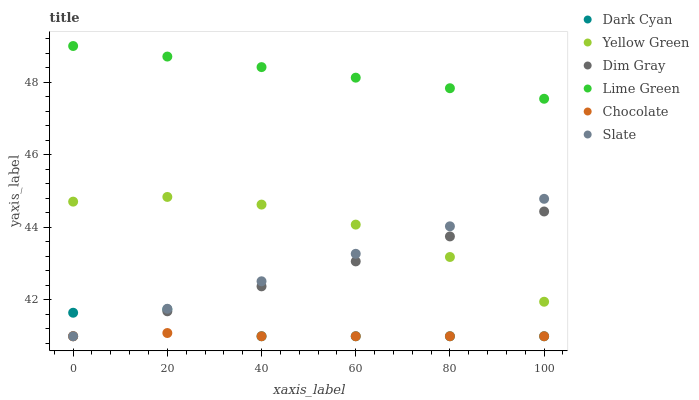Does Chocolate have the minimum area under the curve?
Answer yes or no. Yes. Does Lime Green have the maximum area under the curve?
Answer yes or no. Yes. Does Yellow Green have the minimum area under the curve?
Answer yes or no. No. Does Yellow Green have the maximum area under the curve?
Answer yes or no. No. Is Dim Gray the smoothest?
Answer yes or no. Yes. Is Dark Cyan the roughest?
Answer yes or no. Yes. Is Yellow Green the smoothest?
Answer yes or no. No. Is Yellow Green the roughest?
Answer yes or no. No. Does Dim Gray have the lowest value?
Answer yes or no. Yes. Does Yellow Green have the lowest value?
Answer yes or no. No. Does Lime Green have the highest value?
Answer yes or no. Yes. Does Yellow Green have the highest value?
Answer yes or no. No. Is Dim Gray less than Lime Green?
Answer yes or no. Yes. Is Lime Green greater than Dim Gray?
Answer yes or no. Yes. Does Slate intersect Chocolate?
Answer yes or no. Yes. Is Slate less than Chocolate?
Answer yes or no. No. Is Slate greater than Chocolate?
Answer yes or no. No. Does Dim Gray intersect Lime Green?
Answer yes or no. No. 